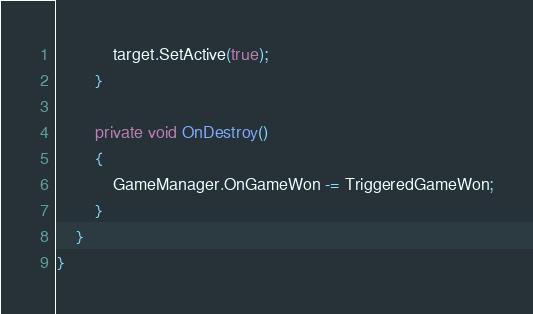Convert code to text. <code><loc_0><loc_0><loc_500><loc_500><_C#_>            target.SetActive(true);
        }

        private void OnDestroy()
        {
            GameManager.OnGameWon -= TriggeredGameWon;
        }
    }
}
</code> 